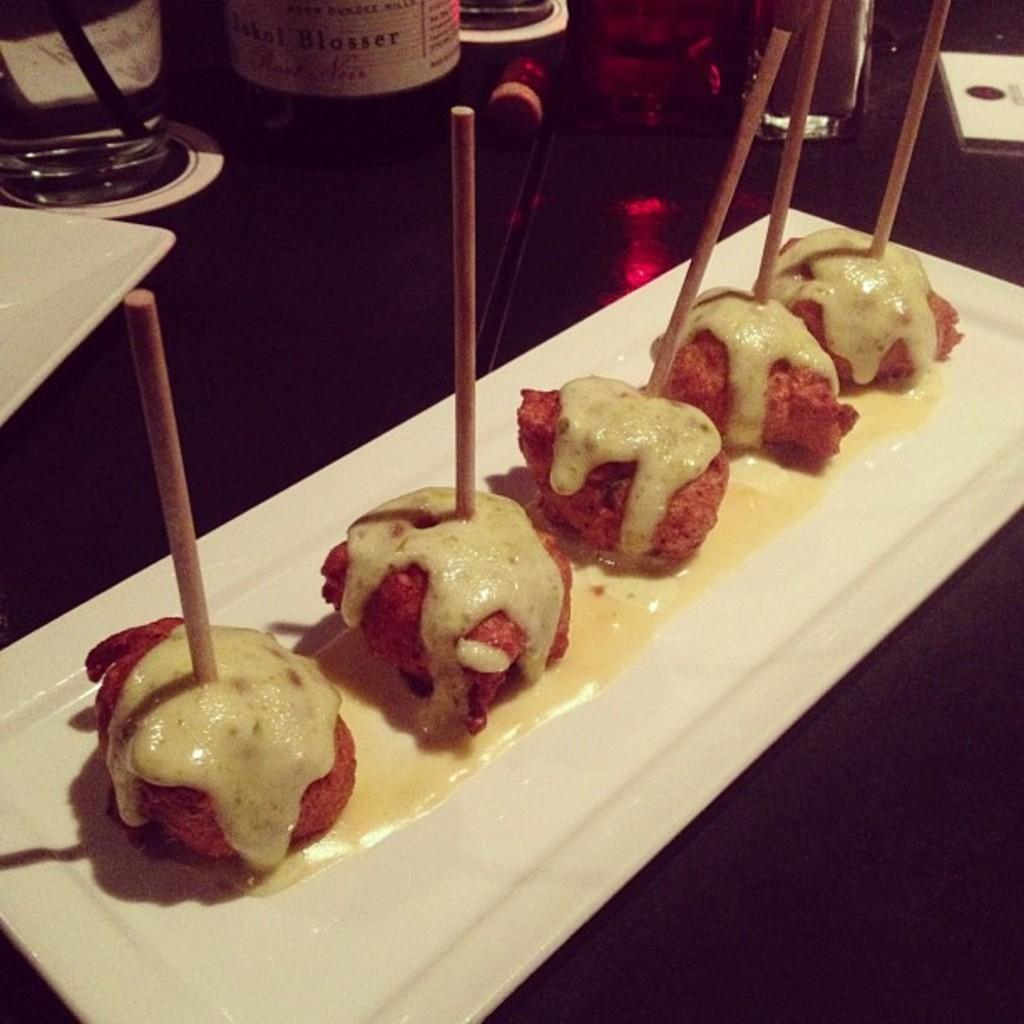What type of items can be seen in the image? There are food items, sticks, glasses, a bottle, and other objects on the table in the image. What are the sticks used for in the image? The sticks are in a plate, which suggests they might be used for eating the food items. What can be used for drinking in the image? There are glasses in the image that can be used for drinking. What might be used for pouring a liquid in the image? The bottle in the image might be used for pouring a liquid. What type of story is being told by the ground in the image? There is no ground visible in the image, and therefore no story can be told by it. What color is the straw in the image? There is no straw present in the image. 